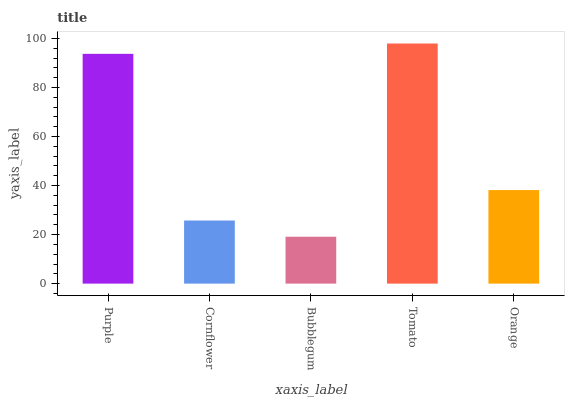Is Bubblegum the minimum?
Answer yes or no. Yes. Is Tomato the maximum?
Answer yes or no. Yes. Is Cornflower the minimum?
Answer yes or no. No. Is Cornflower the maximum?
Answer yes or no. No. Is Purple greater than Cornflower?
Answer yes or no. Yes. Is Cornflower less than Purple?
Answer yes or no. Yes. Is Cornflower greater than Purple?
Answer yes or no. No. Is Purple less than Cornflower?
Answer yes or no. No. Is Orange the high median?
Answer yes or no. Yes. Is Orange the low median?
Answer yes or no. Yes. Is Tomato the high median?
Answer yes or no. No. Is Bubblegum the low median?
Answer yes or no. No. 